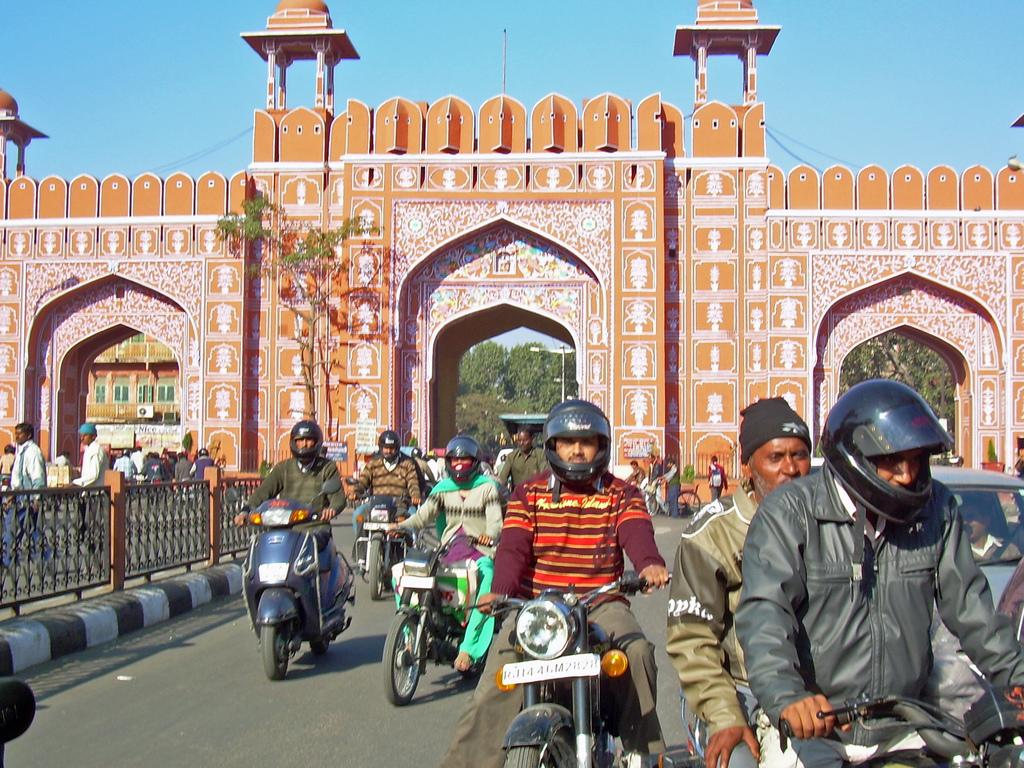Where was the image taken? The image was taken on a road. What can be seen in the image besides the road? There are many people riding motor vehicles in the image. What can be seen in the background of the image? There is a beautifully designed arch in the background of the image. What language is spoken by the people in the image? The image does not provide any information about the language spoken by the people in the image. 